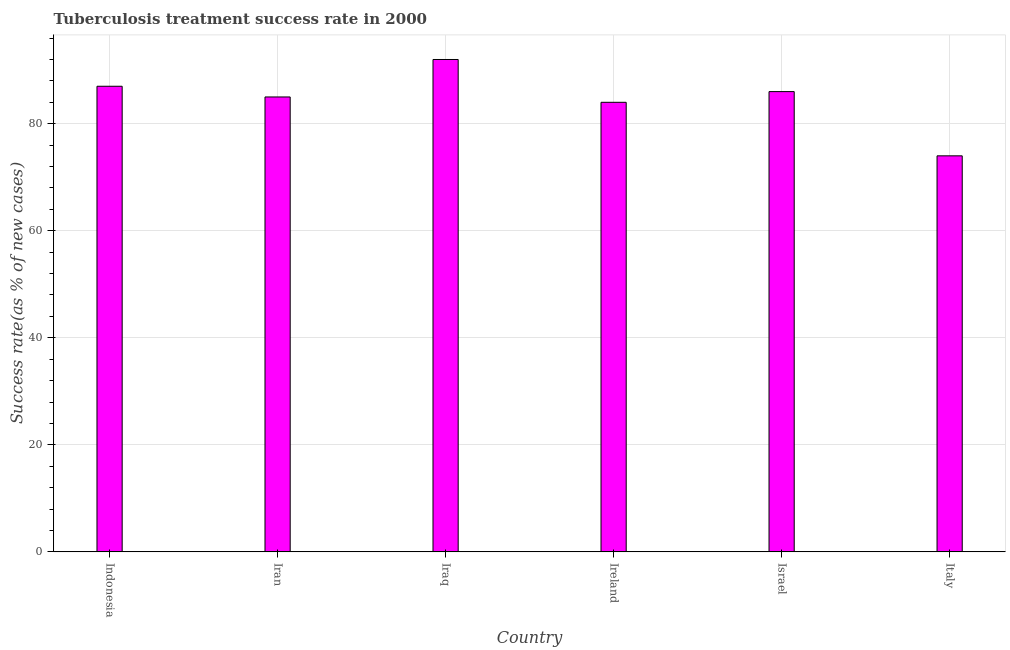Does the graph contain any zero values?
Provide a short and direct response. No. What is the title of the graph?
Your answer should be very brief. Tuberculosis treatment success rate in 2000. What is the label or title of the Y-axis?
Offer a very short reply. Success rate(as % of new cases). What is the tuberculosis treatment success rate in Ireland?
Offer a terse response. 84. Across all countries, what is the maximum tuberculosis treatment success rate?
Offer a very short reply. 92. Across all countries, what is the minimum tuberculosis treatment success rate?
Provide a succinct answer. 74. In which country was the tuberculosis treatment success rate maximum?
Keep it short and to the point. Iraq. What is the sum of the tuberculosis treatment success rate?
Provide a short and direct response. 508. What is the difference between the tuberculosis treatment success rate in Ireland and Italy?
Ensure brevity in your answer.  10. What is the average tuberculosis treatment success rate per country?
Make the answer very short. 84. What is the median tuberculosis treatment success rate?
Your answer should be very brief. 85.5. What is the ratio of the tuberculosis treatment success rate in Iraq to that in Israel?
Your response must be concise. 1.07. Is the tuberculosis treatment success rate in Ireland less than that in Italy?
Offer a very short reply. No. What is the difference between the highest and the second highest tuberculosis treatment success rate?
Keep it short and to the point. 5. What is the difference between the highest and the lowest tuberculosis treatment success rate?
Keep it short and to the point. 18. How many countries are there in the graph?
Your answer should be compact. 6. What is the difference between two consecutive major ticks on the Y-axis?
Ensure brevity in your answer.  20. What is the Success rate(as % of new cases) in Indonesia?
Provide a short and direct response. 87. What is the Success rate(as % of new cases) of Iraq?
Ensure brevity in your answer.  92. What is the Success rate(as % of new cases) in Ireland?
Ensure brevity in your answer.  84. What is the Success rate(as % of new cases) in Italy?
Your answer should be very brief. 74. What is the difference between the Success rate(as % of new cases) in Indonesia and Iraq?
Your answer should be very brief. -5. What is the difference between the Success rate(as % of new cases) in Indonesia and Ireland?
Provide a succinct answer. 3. What is the difference between the Success rate(as % of new cases) in Iran and Ireland?
Give a very brief answer. 1. What is the difference between the Success rate(as % of new cases) in Iran and Israel?
Offer a very short reply. -1. What is the difference between the Success rate(as % of new cases) in Iran and Italy?
Keep it short and to the point. 11. What is the difference between the Success rate(as % of new cases) in Iraq and Israel?
Your answer should be very brief. 6. What is the difference between the Success rate(as % of new cases) in Iraq and Italy?
Your response must be concise. 18. What is the difference between the Success rate(as % of new cases) in Ireland and Israel?
Your answer should be very brief. -2. What is the difference between the Success rate(as % of new cases) in Israel and Italy?
Offer a very short reply. 12. What is the ratio of the Success rate(as % of new cases) in Indonesia to that in Iran?
Provide a succinct answer. 1.02. What is the ratio of the Success rate(as % of new cases) in Indonesia to that in Iraq?
Give a very brief answer. 0.95. What is the ratio of the Success rate(as % of new cases) in Indonesia to that in Ireland?
Make the answer very short. 1.04. What is the ratio of the Success rate(as % of new cases) in Indonesia to that in Italy?
Provide a short and direct response. 1.18. What is the ratio of the Success rate(as % of new cases) in Iran to that in Iraq?
Your answer should be compact. 0.92. What is the ratio of the Success rate(as % of new cases) in Iran to that in Ireland?
Offer a very short reply. 1.01. What is the ratio of the Success rate(as % of new cases) in Iran to that in Italy?
Make the answer very short. 1.15. What is the ratio of the Success rate(as % of new cases) in Iraq to that in Ireland?
Ensure brevity in your answer.  1.09. What is the ratio of the Success rate(as % of new cases) in Iraq to that in Israel?
Offer a very short reply. 1.07. What is the ratio of the Success rate(as % of new cases) in Iraq to that in Italy?
Your answer should be very brief. 1.24. What is the ratio of the Success rate(as % of new cases) in Ireland to that in Israel?
Offer a very short reply. 0.98. What is the ratio of the Success rate(as % of new cases) in Ireland to that in Italy?
Your response must be concise. 1.14. What is the ratio of the Success rate(as % of new cases) in Israel to that in Italy?
Provide a short and direct response. 1.16. 